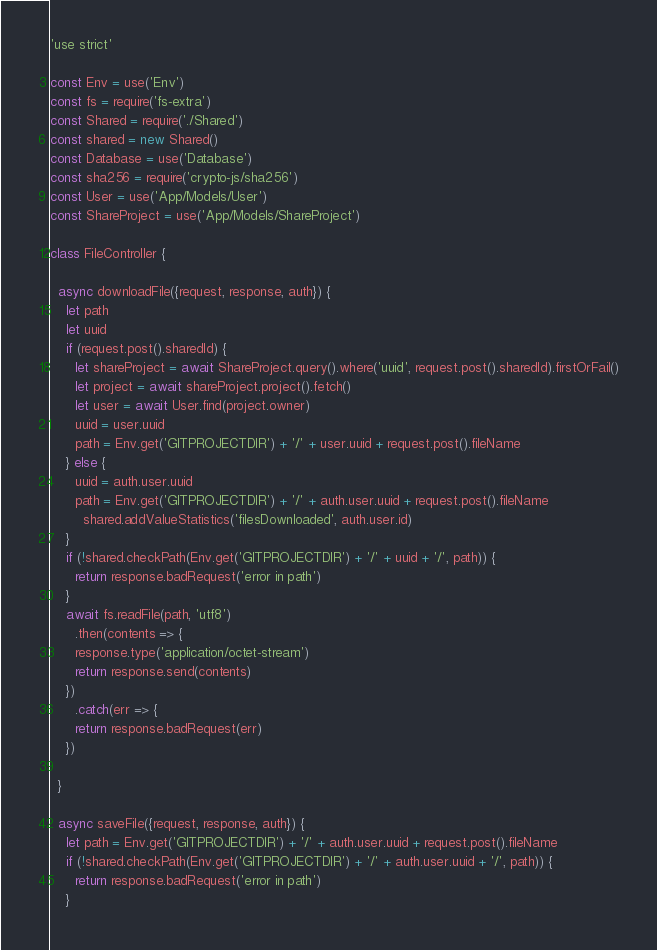Convert code to text. <code><loc_0><loc_0><loc_500><loc_500><_JavaScript_>'use strict'

const Env = use('Env')
const fs = require('fs-extra')
const Shared = require('./Shared')
const shared = new Shared()
const Database = use('Database')
const sha256 = require('crypto-js/sha256')
const User = use('App/Models/User')
const ShareProject = use('App/Models/ShareProject')

class FileController {

  async downloadFile({request, response, auth}) {
    let path
    let uuid
    if (request.post().sharedId) {
      let shareProject = await ShareProject.query().where('uuid', request.post().sharedId).firstOrFail()
      let project = await shareProject.project().fetch()
      let user = await User.find(project.owner)
      uuid = user.uuid
      path = Env.get('GITPROJECTDIR') + '/' + user.uuid + request.post().fileName
    } else {
      uuid = auth.user.uuid
      path = Env.get('GITPROJECTDIR') + '/' + auth.user.uuid + request.post().fileName
    	shared.addValueStatistics('filesDownloaded', auth.user.id)
    }
    if (!shared.checkPath(Env.get('GITPROJECTDIR') + '/' + uuid + '/', path)) {
      return response.badRequest('error in path')
    }
    await fs.readFile(path, 'utf8')
      .then(contents => {
      response.type('application/octet-stream')
      return response.send(contents)
    })
      .catch(err => {
      return response.badRequest(err)
    })

  }

  async saveFile({request, response, auth}) {
    let path = Env.get('GITPROJECTDIR') + '/' + auth.user.uuid + request.post().fileName
    if (!shared.checkPath(Env.get('GITPROJECTDIR') + '/' + auth.user.uuid + '/', path)) {
      return response.badRequest('error in path')
    }</code> 